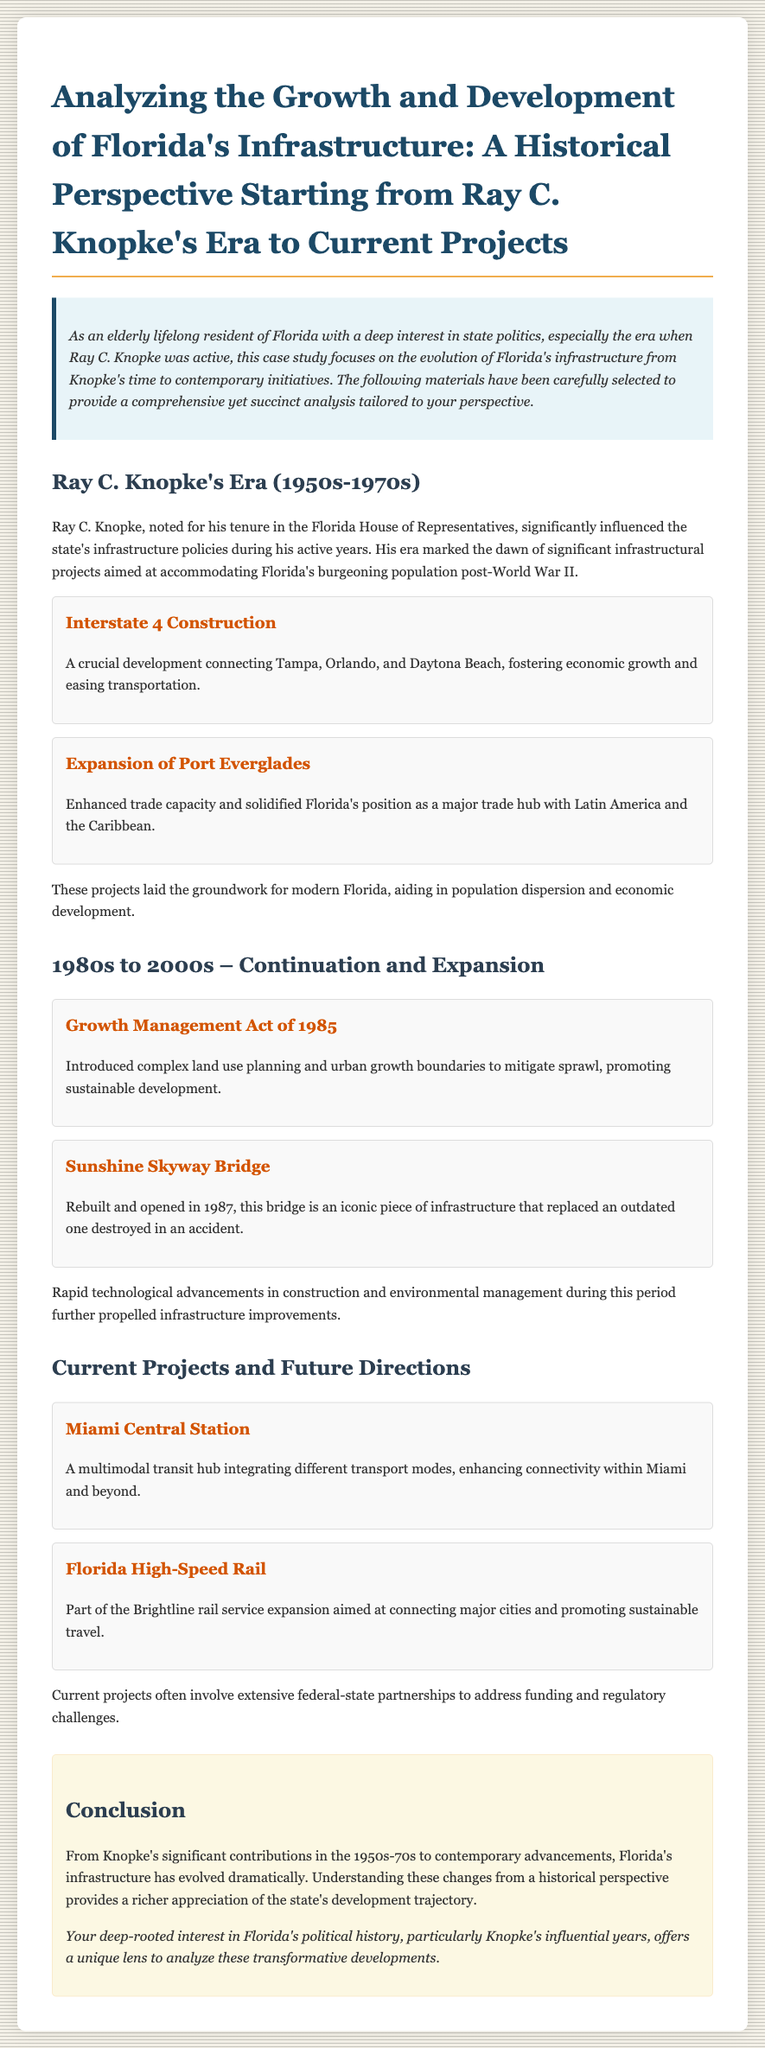What significant project was constructed during Knopke's era? The significant project constructed during Knopke's era is Interstate 4, which connected major cities.
Answer: Interstate 4 What act was introduced in 1985? The act introduced in 1985 was the Growth Management Act, aimed at managing land use.
Answer: Growth Management Act What iconic infrastructure was rebuilt in 1987? The Sunshine Skyway Bridge was rebuilt and opened in 1987 as an iconic piece of infrastructure.
Answer: Sunshine Skyway Bridge What is the purpose of Miami Central Station? Miami Central Station serves as a multimodal transit hub to enhance connectivity within Miami.
Answer: Multimodal transit hub What type of partnership is often involved in current projects? Current projects often involve extensive federal-state partnerships to tackle funding challenges.
Answer: Federal-state partnerships Which project is aimed at promoting sustainable travel? The Florida High-Speed Rail project aims at promoting sustainable travel between major cities.
Answer: Florida High-Speed Rail What period marks Ray C. Knopke's active years in politics? Ray C. Knopke's active years in politics are marked by the 1950s to 1970s.
Answer: 1950s-1970s What is the primary focus of the historical perspective in this case study? The primary focus is on analyzing the growth and development of Florida's infrastructure from Knopke's era to current projects.
Answer: Florida's infrastructure growth and development How does the document describe the impact of Knopke's projects? The document describes Knopke's projects as laying groundwork for modern Florida while aiding population and economic growth.
Answer: Groundwork for modern Florida 